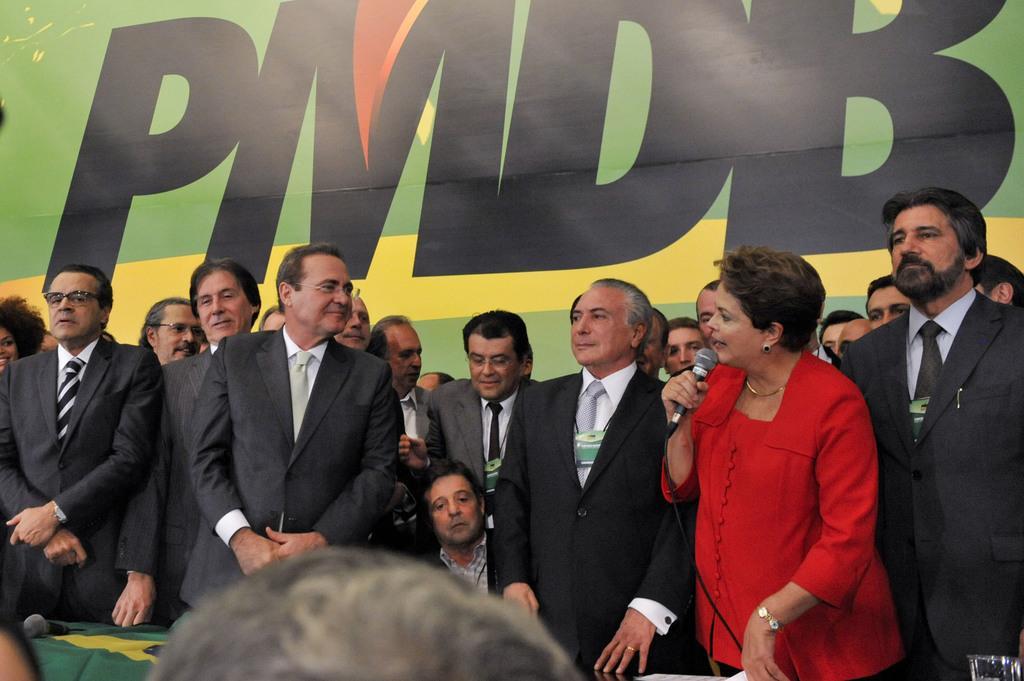How would you summarize this image in a sentence or two? In this image there are men standing, there is a woman holding a microphone and talking, there is a cloth on a table, there is a microphone on the cloth, there is a glass towards the bottom of the image, there is a man towards towards the bottom of the image, at the background of the image there is a board, there is text on the board. 